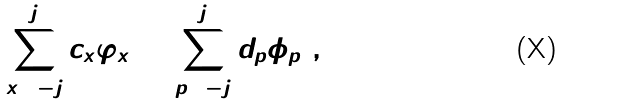Convert formula to latex. <formula><loc_0><loc_0><loc_500><loc_500>\Psi = \sum _ { x = - j } ^ { j } c _ { x } \varphi _ { x } = \sum _ { p = - j } ^ { j } d _ { p } \phi _ { p } \ ,</formula> 